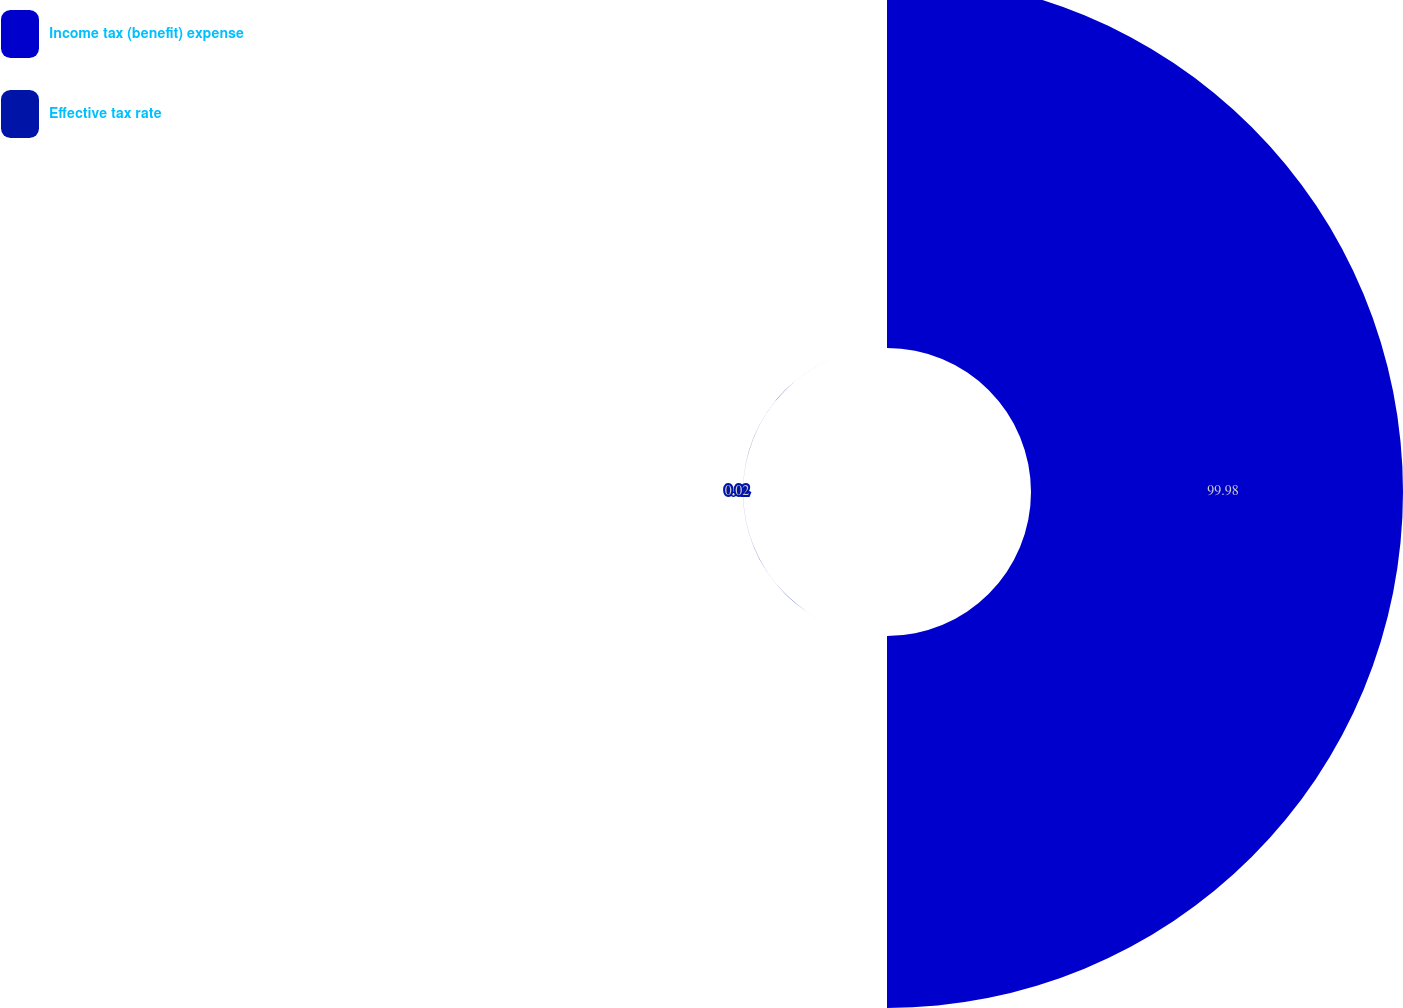Convert chart. <chart><loc_0><loc_0><loc_500><loc_500><pie_chart><fcel>Income tax (benefit) expense<fcel>Effective tax rate<nl><fcel>99.98%<fcel>0.02%<nl></chart> 